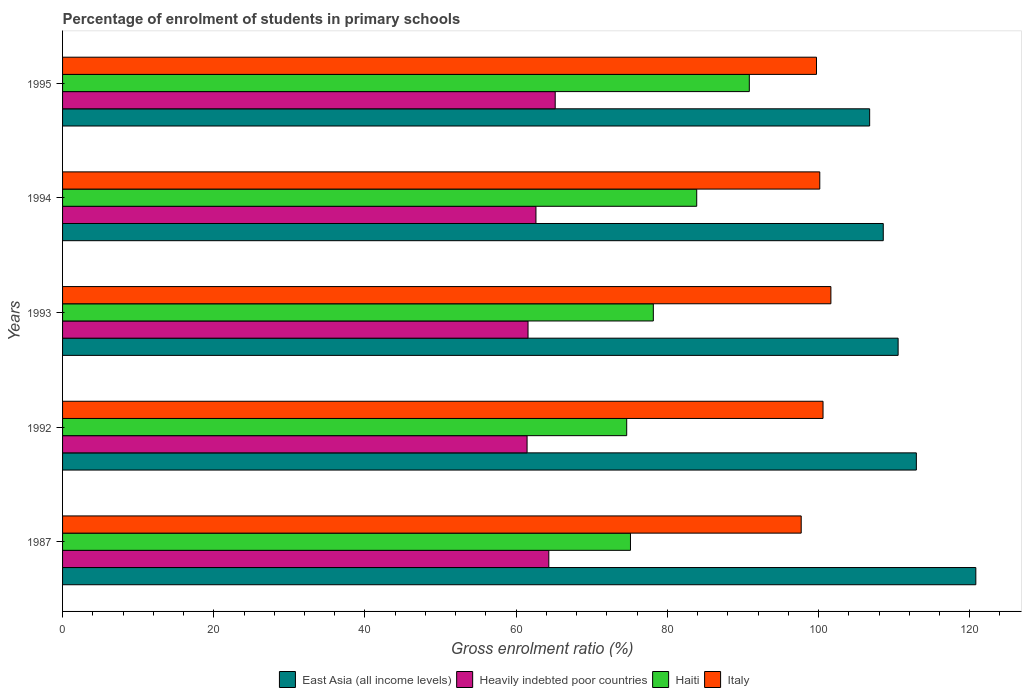How many different coloured bars are there?
Offer a terse response. 4. How many groups of bars are there?
Offer a very short reply. 5. Are the number of bars per tick equal to the number of legend labels?
Ensure brevity in your answer.  Yes. Are the number of bars on each tick of the Y-axis equal?
Your response must be concise. Yes. How many bars are there on the 1st tick from the top?
Make the answer very short. 4. How many bars are there on the 5th tick from the bottom?
Provide a short and direct response. 4. What is the label of the 2nd group of bars from the top?
Provide a succinct answer. 1994. What is the percentage of students enrolled in primary schools in Heavily indebted poor countries in 1995?
Provide a short and direct response. 65.17. Across all years, what is the maximum percentage of students enrolled in primary schools in Heavily indebted poor countries?
Offer a terse response. 65.17. Across all years, what is the minimum percentage of students enrolled in primary schools in Italy?
Ensure brevity in your answer.  97.71. In which year was the percentage of students enrolled in primary schools in Heavily indebted poor countries minimum?
Provide a succinct answer. 1992. What is the total percentage of students enrolled in primary schools in East Asia (all income levels) in the graph?
Keep it short and to the point. 559.62. What is the difference between the percentage of students enrolled in primary schools in East Asia (all income levels) in 1992 and that in 1995?
Give a very brief answer. 6.18. What is the difference between the percentage of students enrolled in primary schools in East Asia (all income levels) in 1992 and the percentage of students enrolled in primary schools in Haiti in 1995?
Your answer should be very brief. 22.1. What is the average percentage of students enrolled in primary schools in Haiti per year?
Your answer should be very brief. 80.53. In the year 1994, what is the difference between the percentage of students enrolled in primary schools in East Asia (all income levels) and percentage of students enrolled in primary schools in Italy?
Give a very brief answer. 8.4. What is the ratio of the percentage of students enrolled in primary schools in Heavily indebted poor countries in 1987 to that in 1993?
Make the answer very short. 1.04. Is the difference between the percentage of students enrolled in primary schools in East Asia (all income levels) in 1987 and 1995 greater than the difference between the percentage of students enrolled in primary schools in Italy in 1987 and 1995?
Your answer should be compact. Yes. What is the difference between the highest and the second highest percentage of students enrolled in primary schools in Heavily indebted poor countries?
Your response must be concise. 0.85. What is the difference between the highest and the lowest percentage of students enrolled in primary schools in East Asia (all income levels)?
Your answer should be very brief. 14.04. What does the 4th bar from the top in 1995 represents?
Offer a terse response. East Asia (all income levels). What does the 3rd bar from the bottom in 1994 represents?
Provide a succinct answer. Haiti. Are the values on the major ticks of X-axis written in scientific E-notation?
Your response must be concise. No. How many legend labels are there?
Your response must be concise. 4. How are the legend labels stacked?
Your response must be concise. Horizontal. What is the title of the graph?
Keep it short and to the point. Percentage of enrolment of students in primary schools. What is the label or title of the X-axis?
Offer a very short reply. Gross enrolment ratio (%). What is the Gross enrolment ratio (%) in East Asia (all income levels) in 1987?
Give a very brief answer. 120.81. What is the Gross enrolment ratio (%) of Heavily indebted poor countries in 1987?
Provide a short and direct response. 64.32. What is the Gross enrolment ratio (%) in Haiti in 1987?
Your answer should be compact. 75.12. What is the Gross enrolment ratio (%) in Italy in 1987?
Keep it short and to the point. 97.71. What is the Gross enrolment ratio (%) in East Asia (all income levels) in 1992?
Your answer should be very brief. 112.94. What is the Gross enrolment ratio (%) in Heavily indebted poor countries in 1992?
Offer a very short reply. 61.45. What is the Gross enrolment ratio (%) in Haiti in 1992?
Offer a terse response. 74.63. What is the Gross enrolment ratio (%) of Italy in 1992?
Keep it short and to the point. 100.6. What is the Gross enrolment ratio (%) in East Asia (all income levels) in 1993?
Your response must be concise. 110.53. What is the Gross enrolment ratio (%) of Heavily indebted poor countries in 1993?
Give a very brief answer. 61.57. What is the Gross enrolment ratio (%) in Haiti in 1993?
Give a very brief answer. 78.15. What is the Gross enrolment ratio (%) in Italy in 1993?
Your answer should be very brief. 101.64. What is the Gross enrolment ratio (%) of East Asia (all income levels) in 1994?
Offer a very short reply. 108.56. What is the Gross enrolment ratio (%) in Heavily indebted poor countries in 1994?
Ensure brevity in your answer.  62.62. What is the Gross enrolment ratio (%) in Haiti in 1994?
Make the answer very short. 83.89. What is the Gross enrolment ratio (%) of Italy in 1994?
Keep it short and to the point. 100.17. What is the Gross enrolment ratio (%) of East Asia (all income levels) in 1995?
Ensure brevity in your answer.  106.77. What is the Gross enrolment ratio (%) of Heavily indebted poor countries in 1995?
Your answer should be very brief. 65.17. What is the Gross enrolment ratio (%) of Haiti in 1995?
Provide a short and direct response. 90.84. What is the Gross enrolment ratio (%) in Italy in 1995?
Keep it short and to the point. 99.73. Across all years, what is the maximum Gross enrolment ratio (%) in East Asia (all income levels)?
Give a very brief answer. 120.81. Across all years, what is the maximum Gross enrolment ratio (%) of Heavily indebted poor countries?
Give a very brief answer. 65.17. Across all years, what is the maximum Gross enrolment ratio (%) in Haiti?
Provide a short and direct response. 90.84. Across all years, what is the maximum Gross enrolment ratio (%) in Italy?
Provide a short and direct response. 101.64. Across all years, what is the minimum Gross enrolment ratio (%) in East Asia (all income levels)?
Make the answer very short. 106.77. Across all years, what is the minimum Gross enrolment ratio (%) in Heavily indebted poor countries?
Provide a short and direct response. 61.45. Across all years, what is the minimum Gross enrolment ratio (%) in Haiti?
Your answer should be very brief. 74.63. Across all years, what is the minimum Gross enrolment ratio (%) in Italy?
Your response must be concise. 97.71. What is the total Gross enrolment ratio (%) in East Asia (all income levels) in the graph?
Offer a terse response. 559.62. What is the total Gross enrolment ratio (%) of Heavily indebted poor countries in the graph?
Provide a short and direct response. 315.13. What is the total Gross enrolment ratio (%) in Haiti in the graph?
Keep it short and to the point. 402.63. What is the total Gross enrolment ratio (%) in Italy in the graph?
Provide a succinct answer. 499.84. What is the difference between the Gross enrolment ratio (%) of East Asia (all income levels) in 1987 and that in 1992?
Your answer should be very brief. 7.87. What is the difference between the Gross enrolment ratio (%) of Heavily indebted poor countries in 1987 and that in 1992?
Your response must be concise. 2.87. What is the difference between the Gross enrolment ratio (%) in Haiti in 1987 and that in 1992?
Your answer should be very brief. 0.5. What is the difference between the Gross enrolment ratio (%) of Italy in 1987 and that in 1992?
Ensure brevity in your answer.  -2.89. What is the difference between the Gross enrolment ratio (%) of East Asia (all income levels) in 1987 and that in 1993?
Give a very brief answer. 10.28. What is the difference between the Gross enrolment ratio (%) of Heavily indebted poor countries in 1987 and that in 1993?
Keep it short and to the point. 2.75. What is the difference between the Gross enrolment ratio (%) in Haiti in 1987 and that in 1993?
Provide a succinct answer. -3.02. What is the difference between the Gross enrolment ratio (%) of Italy in 1987 and that in 1993?
Provide a succinct answer. -3.93. What is the difference between the Gross enrolment ratio (%) in East Asia (all income levels) in 1987 and that in 1994?
Your answer should be compact. 12.25. What is the difference between the Gross enrolment ratio (%) in Heavily indebted poor countries in 1987 and that in 1994?
Provide a short and direct response. 1.7. What is the difference between the Gross enrolment ratio (%) in Haiti in 1987 and that in 1994?
Your answer should be compact. -8.76. What is the difference between the Gross enrolment ratio (%) of Italy in 1987 and that in 1994?
Make the answer very short. -2.46. What is the difference between the Gross enrolment ratio (%) of East Asia (all income levels) in 1987 and that in 1995?
Offer a terse response. 14.04. What is the difference between the Gross enrolment ratio (%) of Heavily indebted poor countries in 1987 and that in 1995?
Provide a short and direct response. -0.85. What is the difference between the Gross enrolment ratio (%) in Haiti in 1987 and that in 1995?
Make the answer very short. -15.72. What is the difference between the Gross enrolment ratio (%) of Italy in 1987 and that in 1995?
Make the answer very short. -2.02. What is the difference between the Gross enrolment ratio (%) in East Asia (all income levels) in 1992 and that in 1993?
Offer a terse response. 2.41. What is the difference between the Gross enrolment ratio (%) in Heavily indebted poor countries in 1992 and that in 1993?
Make the answer very short. -0.13. What is the difference between the Gross enrolment ratio (%) in Haiti in 1992 and that in 1993?
Your answer should be compact. -3.52. What is the difference between the Gross enrolment ratio (%) in Italy in 1992 and that in 1993?
Offer a very short reply. -1.04. What is the difference between the Gross enrolment ratio (%) of East Asia (all income levels) in 1992 and that in 1994?
Provide a succinct answer. 4.38. What is the difference between the Gross enrolment ratio (%) in Heavily indebted poor countries in 1992 and that in 1994?
Your response must be concise. -1.17. What is the difference between the Gross enrolment ratio (%) in Haiti in 1992 and that in 1994?
Keep it short and to the point. -9.26. What is the difference between the Gross enrolment ratio (%) of Italy in 1992 and that in 1994?
Your response must be concise. 0.43. What is the difference between the Gross enrolment ratio (%) of East Asia (all income levels) in 1992 and that in 1995?
Your response must be concise. 6.18. What is the difference between the Gross enrolment ratio (%) of Heavily indebted poor countries in 1992 and that in 1995?
Give a very brief answer. -3.72. What is the difference between the Gross enrolment ratio (%) in Haiti in 1992 and that in 1995?
Make the answer very short. -16.22. What is the difference between the Gross enrolment ratio (%) in Italy in 1992 and that in 1995?
Keep it short and to the point. 0.86. What is the difference between the Gross enrolment ratio (%) of East Asia (all income levels) in 1993 and that in 1994?
Your answer should be compact. 1.97. What is the difference between the Gross enrolment ratio (%) of Heavily indebted poor countries in 1993 and that in 1994?
Your answer should be very brief. -1.05. What is the difference between the Gross enrolment ratio (%) of Haiti in 1993 and that in 1994?
Ensure brevity in your answer.  -5.74. What is the difference between the Gross enrolment ratio (%) in Italy in 1993 and that in 1994?
Your answer should be very brief. 1.47. What is the difference between the Gross enrolment ratio (%) in East Asia (all income levels) in 1993 and that in 1995?
Your answer should be compact. 3.77. What is the difference between the Gross enrolment ratio (%) of Heavily indebted poor countries in 1993 and that in 1995?
Offer a terse response. -3.59. What is the difference between the Gross enrolment ratio (%) of Haiti in 1993 and that in 1995?
Provide a succinct answer. -12.7. What is the difference between the Gross enrolment ratio (%) in Italy in 1993 and that in 1995?
Offer a terse response. 1.9. What is the difference between the Gross enrolment ratio (%) of East Asia (all income levels) in 1994 and that in 1995?
Provide a short and direct response. 1.8. What is the difference between the Gross enrolment ratio (%) in Heavily indebted poor countries in 1994 and that in 1995?
Provide a short and direct response. -2.55. What is the difference between the Gross enrolment ratio (%) in Haiti in 1994 and that in 1995?
Make the answer very short. -6.96. What is the difference between the Gross enrolment ratio (%) in Italy in 1994 and that in 1995?
Provide a succinct answer. 0.43. What is the difference between the Gross enrolment ratio (%) in East Asia (all income levels) in 1987 and the Gross enrolment ratio (%) in Heavily indebted poor countries in 1992?
Keep it short and to the point. 59.36. What is the difference between the Gross enrolment ratio (%) in East Asia (all income levels) in 1987 and the Gross enrolment ratio (%) in Haiti in 1992?
Offer a terse response. 46.18. What is the difference between the Gross enrolment ratio (%) in East Asia (all income levels) in 1987 and the Gross enrolment ratio (%) in Italy in 1992?
Provide a succinct answer. 20.21. What is the difference between the Gross enrolment ratio (%) in Heavily indebted poor countries in 1987 and the Gross enrolment ratio (%) in Haiti in 1992?
Provide a succinct answer. -10.3. What is the difference between the Gross enrolment ratio (%) in Heavily indebted poor countries in 1987 and the Gross enrolment ratio (%) in Italy in 1992?
Make the answer very short. -36.27. What is the difference between the Gross enrolment ratio (%) in Haiti in 1987 and the Gross enrolment ratio (%) in Italy in 1992?
Offer a very short reply. -25.47. What is the difference between the Gross enrolment ratio (%) in East Asia (all income levels) in 1987 and the Gross enrolment ratio (%) in Heavily indebted poor countries in 1993?
Make the answer very short. 59.24. What is the difference between the Gross enrolment ratio (%) of East Asia (all income levels) in 1987 and the Gross enrolment ratio (%) of Haiti in 1993?
Your response must be concise. 42.66. What is the difference between the Gross enrolment ratio (%) in East Asia (all income levels) in 1987 and the Gross enrolment ratio (%) in Italy in 1993?
Your response must be concise. 19.17. What is the difference between the Gross enrolment ratio (%) of Heavily indebted poor countries in 1987 and the Gross enrolment ratio (%) of Haiti in 1993?
Offer a terse response. -13.83. What is the difference between the Gross enrolment ratio (%) of Heavily indebted poor countries in 1987 and the Gross enrolment ratio (%) of Italy in 1993?
Your response must be concise. -37.31. What is the difference between the Gross enrolment ratio (%) of Haiti in 1987 and the Gross enrolment ratio (%) of Italy in 1993?
Your answer should be compact. -26.51. What is the difference between the Gross enrolment ratio (%) of East Asia (all income levels) in 1987 and the Gross enrolment ratio (%) of Heavily indebted poor countries in 1994?
Offer a terse response. 58.19. What is the difference between the Gross enrolment ratio (%) in East Asia (all income levels) in 1987 and the Gross enrolment ratio (%) in Haiti in 1994?
Offer a very short reply. 36.92. What is the difference between the Gross enrolment ratio (%) of East Asia (all income levels) in 1987 and the Gross enrolment ratio (%) of Italy in 1994?
Provide a short and direct response. 20.64. What is the difference between the Gross enrolment ratio (%) of Heavily indebted poor countries in 1987 and the Gross enrolment ratio (%) of Haiti in 1994?
Offer a very short reply. -19.57. What is the difference between the Gross enrolment ratio (%) of Heavily indebted poor countries in 1987 and the Gross enrolment ratio (%) of Italy in 1994?
Provide a succinct answer. -35.84. What is the difference between the Gross enrolment ratio (%) of Haiti in 1987 and the Gross enrolment ratio (%) of Italy in 1994?
Make the answer very short. -25.04. What is the difference between the Gross enrolment ratio (%) of East Asia (all income levels) in 1987 and the Gross enrolment ratio (%) of Heavily indebted poor countries in 1995?
Provide a succinct answer. 55.64. What is the difference between the Gross enrolment ratio (%) in East Asia (all income levels) in 1987 and the Gross enrolment ratio (%) in Haiti in 1995?
Your response must be concise. 29.97. What is the difference between the Gross enrolment ratio (%) of East Asia (all income levels) in 1987 and the Gross enrolment ratio (%) of Italy in 1995?
Give a very brief answer. 21.08. What is the difference between the Gross enrolment ratio (%) of Heavily indebted poor countries in 1987 and the Gross enrolment ratio (%) of Haiti in 1995?
Offer a terse response. -26.52. What is the difference between the Gross enrolment ratio (%) in Heavily indebted poor countries in 1987 and the Gross enrolment ratio (%) in Italy in 1995?
Your answer should be compact. -35.41. What is the difference between the Gross enrolment ratio (%) of Haiti in 1987 and the Gross enrolment ratio (%) of Italy in 1995?
Keep it short and to the point. -24.61. What is the difference between the Gross enrolment ratio (%) of East Asia (all income levels) in 1992 and the Gross enrolment ratio (%) of Heavily indebted poor countries in 1993?
Give a very brief answer. 51.37. What is the difference between the Gross enrolment ratio (%) in East Asia (all income levels) in 1992 and the Gross enrolment ratio (%) in Haiti in 1993?
Give a very brief answer. 34.79. What is the difference between the Gross enrolment ratio (%) of East Asia (all income levels) in 1992 and the Gross enrolment ratio (%) of Italy in 1993?
Provide a short and direct response. 11.31. What is the difference between the Gross enrolment ratio (%) in Heavily indebted poor countries in 1992 and the Gross enrolment ratio (%) in Haiti in 1993?
Give a very brief answer. -16.7. What is the difference between the Gross enrolment ratio (%) in Heavily indebted poor countries in 1992 and the Gross enrolment ratio (%) in Italy in 1993?
Ensure brevity in your answer.  -40.19. What is the difference between the Gross enrolment ratio (%) of Haiti in 1992 and the Gross enrolment ratio (%) of Italy in 1993?
Ensure brevity in your answer.  -27.01. What is the difference between the Gross enrolment ratio (%) of East Asia (all income levels) in 1992 and the Gross enrolment ratio (%) of Heavily indebted poor countries in 1994?
Provide a short and direct response. 50.32. What is the difference between the Gross enrolment ratio (%) of East Asia (all income levels) in 1992 and the Gross enrolment ratio (%) of Haiti in 1994?
Ensure brevity in your answer.  29.05. What is the difference between the Gross enrolment ratio (%) in East Asia (all income levels) in 1992 and the Gross enrolment ratio (%) in Italy in 1994?
Ensure brevity in your answer.  12.78. What is the difference between the Gross enrolment ratio (%) of Heavily indebted poor countries in 1992 and the Gross enrolment ratio (%) of Haiti in 1994?
Ensure brevity in your answer.  -22.44. What is the difference between the Gross enrolment ratio (%) in Heavily indebted poor countries in 1992 and the Gross enrolment ratio (%) in Italy in 1994?
Provide a succinct answer. -38.72. What is the difference between the Gross enrolment ratio (%) of Haiti in 1992 and the Gross enrolment ratio (%) of Italy in 1994?
Provide a short and direct response. -25.54. What is the difference between the Gross enrolment ratio (%) of East Asia (all income levels) in 1992 and the Gross enrolment ratio (%) of Heavily indebted poor countries in 1995?
Provide a succinct answer. 47.77. What is the difference between the Gross enrolment ratio (%) in East Asia (all income levels) in 1992 and the Gross enrolment ratio (%) in Haiti in 1995?
Make the answer very short. 22.1. What is the difference between the Gross enrolment ratio (%) in East Asia (all income levels) in 1992 and the Gross enrolment ratio (%) in Italy in 1995?
Provide a succinct answer. 13.21. What is the difference between the Gross enrolment ratio (%) in Heavily indebted poor countries in 1992 and the Gross enrolment ratio (%) in Haiti in 1995?
Your answer should be compact. -29.4. What is the difference between the Gross enrolment ratio (%) in Heavily indebted poor countries in 1992 and the Gross enrolment ratio (%) in Italy in 1995?
Your response must be concise. -38.28. What is the difference between the Gross enrolment ratio (%) in Haiti in 1992 and the Gross enrolment ratio (%) in Italy in 1995?
Ensure brevity in your answer.  -25.11. What is the difference between the Gross enrolment ratio (%) in East Asia (all income levels) in 1993 and the Gross enrolment ratio (%) in Heavily indebted poor countries in 1994?
Your answer should be compact. 47.91. What is the difference between the Gross enrolment ratio (%) in East Asia (all income levels) in 1993 and the Gross enrolment ratio (%) in Haiti in 1994?
Offer a terse response. 26.64. What is the difference between the Gross enrolment ratio (%) in East Asia (all income levels) in 1993 and the Gross enrolment ratio (%) in Italy in 1994?
Keep it short and to the point. 10.36. What is the difference between the Gross enrolment ratio (%) of Heavily indebted poor countries in 1993 and the Gross enrolment ratio (%) of Haiti in 1994?
Provide a succinct answer. -22.31. What is the difference between the Gross enrolment ratio (%) in Heavily indebted poor countries in 1993 and the Gross enrolment ratio (%) in Italy in 1994?
Ensure brevity in your answer.  -38.59. What is the difference between the Gross enrolment ratio (%) in Haiti in 1993 and the Gross enrolment ratio (%) in Italy in 1994?
Give a very brief answer. -22.02. What is the difference between the Gross enrolment ratio (%) of East Asia (all income levels) in 1993 and the Gross enrolment ratio (%) of Heavily indebted poor countries in 1995?
Offer a very short reply. 45.36. What is the difference between the Gross enrolment ratio (%) of East Asia (all income levels) in 1993 and the Gross enrolment ratio (%) of Haiti in 1995?
Give a very brief answer. 19.69. What is the difference between the Gross enrolment ratio (%) of East Asia (all income levels) in 1993 and the Gross enrolment ratio (%) of Italy in 1995?
Ensure brevity in your answer.  10.8. What is the difference between the Gross enrolment ratio (%) in Heavily indebted poor countries in 1993 and the Gross enrolment ratio (%) in Haiti in 1995?
Provide a succinct answer. -29.27. What is the difference between the Gross enrolment ratio (%) of Heavily indebted poor countries in 1993 and the Gross enrolment ratio (%) of Italy in 1995?
Give a very brief answer. -38.16. What is the difference between the Gross enrolment ratio (%) in Haiti in 1993 and the Gross enrolment ratio (%) in Italy in 1995?
Your answer should be very brief. -21.58. What is the difference between the Gross enrolment ratio (%) of East Asia (all income levels) in 1994 and the Gross enrolment ratio (%) of Heavily indebted poor countries in 1995?
Keep it short and to the point. 43.4. What is the difference between the Gross enrolment ratio (%) in East Asia (all income levels) in 1994 and the Gross enrolment ratio (%) in Haiti in 1995?
Provide a short and direct response. 17.72. What is the difference between the Gross enrolment ratio (%) of East Asia (all income levels) in 1994 and the Gross enrolment ratio (%) of Italy in 1995?
Your answer should be compact. 8.83. What is the difference between the Gross enrolment ratio (%) of Heavily indebted poor countries in 1994 and the Gross enrolment ratio (%) of Haiti in 1995?
Your response must be concise. -28.22. What is the difference between the Gross enrolment ratio (%) of Heavily indebted poor countries in 1994 and the Gross enrolment ratio (%) of Italy in 1995?
Offer a very short reply. -37.11. What is the difference between the Gross enrolment ratio (%) of Haiti in 1994 and the Gross enrolment ratio (%) of Italy in 1995?
Keep it short and to the point. -15.84. What is the average Gross enrolment ratio (%) in East Asia (all income levels) per year?
Offer a very short reply. 111.92. What is the average Gross enrolment ratio (%) in Heavily indebted poor countries per year?
Your response must be concise. 63.03. What is the average Gross enrolment ratio (%) in Haiti per year?
Give a very brief answer. 80.53. What is the average Gross enrolment ratio (%) of Italy per year?
Make the answer very short. 99.97. In the year 1987, what is the difference between the Gross enrolment ratio (%) in East Asia (all income levels) and Gross enrolment ratio (%) in Heavily indebted poor countries?
Your answer should be very brief. 56.49. In the year 1987, what is the difference between the Gross enrolment ratio (%) of East Asia (all income levels) and Gross enrolment ratio (%) of Haiti?
Give a very brief answer. 45.69. In the year 1987, what is the difference between the Gross enrolment ratio (%) of East Asia (all income levels) and Gross enrolment ratio (%) of Italy?
Your response must be concise. 23.1. In the year 1987, what is the difference between the Gross enrolment ratio (%) in Heavily indebted poor countries and Gross enrolment ratio (%) in Haiti?
Your response must be concise. -10.8. In the year 1987, what is the difference between the Gross enrolment ratio (%) in Heavily indebted poor countries and Gross enrolment ratio (%) in Italy?
Ensure brevity in your answer.  -33.39. In the year 1987, what is the difference between the Gross enrolment ratio (%) in Haiti and Gross enrolment ratio (%) in Italy?
Offer a very short reply. -22.58. In the year 1992, what is the difference between the Gross enrolment ratio (%) of East Asia (all income levels) and Gross enrolment ratio (%) of Heavily indebted poor countries?
Give a very brief answer. 51.5. In the year 1992, what is the difference between the Gross enrolment ratio (%) in East Asia (all income levels) and Gross enrolment ratio (%) in Haiti?
Ensure brevity in your answer.  38.32. In the year 1992, what is the difference between the Gross enrolment ratio (%) of East Asia (all income levels) and Gross enrolment ratio (%) of Italy?
Keep it short and to the point. 12.35. In the year 1992, what is the difference between the Gross enrolment ratio (%) of Heavily indebted poor countries and Gross enrolment ratio (%) of Haiti?
Make the answer very short. -13.18. In the year 1992, what is the difference between the Gross enrolment ratio (%) in Heavily indebted poor countries and Gross enrolment ratio (%) in Italy?
Provide a short and direct response. -39.15. In the year 1992, what is the difference between the Gross enrolment ratio (%) of Haiti and Gross enrolment ratio (%) of Italy?
Ensure brevity in your answer.  -25.97. In the year 1993, what is the difference between the Gross enrolment ratio (%) in East Asia (all income levels) and Gross enrolment ratio (%) in Heavily indebted poor countries?
Offer a terse response. 48.96. In the year 1993, what is the difference between the Gross enrolment ratio (%) of East Asia (all income levels) and Gross enrolment ratio (%) of Haiti?
Make the answer very short. 32.38. In the year 1993, what is the difference between the Gross enrolment ratio (%) of East Asia (all income levels) and Gross enrolment ratio (%) of Italy?
Make the answer very short. 8.89. In the year 1993, what is the difference between the Gross enrolment ratio (%) in Heavily indebted poor countries and Gross enrolment ratio (%) in Haiti?
Keep it short and to the point. -16.57. In the year 1993, what is the difference between the Gross enrolment ratio (%) in Heavily indebted poor countries and Gross enrolment ratio (%) in Italy?
Ensure brevity in your answer.  -40.06. In the year 1993, what is the difference between the Gross enrolment ratio (%) of Haiti and Gross enrolment ratio (%) of Italy?
Provide a short and direct response. -23.49. In the year 1994, what is the difference between the Gross enrolment ratio (%) of East Asia (all income levels) and Gross enrolment ratio (%) of Heavily indebted poor countries?
Offer a very short reply. 45.94. In the year 1994, what is the difference between the Gross enrolment ratio (%) of East Asia (all income levels) and Gross enrolment ratio (%) of Haiti?
Make the answer very short. 24.68. In the year 1994, what is the difference between the Gross enrolment ratio (%) in East Asia (all income levels) and Gross enrolment ratio (%) in Italy?
Provide a short and direct response. 8.4. In the year 1994, what is the difference between the Gross enrolment ratio (%) of Heavily indebted poor countries and Gross enrolment ratio (%) of Haiti?
Make the answer very short. -21.27. In the year 1994, what is the difference between the Gross enrolment ratio (%) in Heavily indebted poor countries and Gross enrolment ratio (%) in Italy?
Provide a short and direct response. -37.55. In the year 1994, what is the difference between the Gross enrolment ratio (%) in Haiti and Gross enrolment ratio (%) in Italy?
Give a very brief answer. -16.28. In the year 1995, what is the difference between the Gross enrolment ratio (%) in East Asia (all income levels) and Gross enrolment ratio (%) in Heavily indebted poor countries?
Provide a short and direct response. 41.6. In the year 1995, what is the difference between the Gross enrolment ratio (%) in East Asia (all income levels) and Gross enrolment ratio (%) in Haiti?
Make the answer very short. 15.92. In the year 1995, what is the difference between the Gross enrolment ratio (%) in East Asia (all income levels) and Gross enrolment ratio (%) in Italy?
Make the answer very short. 7.03. In the year 1995, what is the difference between the Gross enrolment ratio (%) in Heavily indebted poor countries and Gross enrolment ratio (%) in Haiti?
Your answer should be compact. -25.68. In the year 1995, what is the difference between the Gross enrolment ratio (%) of Heavily indebted poor countries and Gross enrolment ratio (%) of Italy?
Ensure brevity in your answer.  -34.56. In the year 1995, what is the difference between the Gross enrolment ratio (%) in Haiti and Gross enrolment ratio (%) in Italy?
Give a very brief answer. -8.89. What is the ratio of the Gross enrolment ratio (%) of East Asia (all income levels) in 1987 to that in 1992?
Give a very brief answer. 1.07. What is the ratio of the Gross enrolment ratio (%) in Heavily indebted poor countries in 1987 to that in 1992?
Give a very brief answer. 1.05. What is the ratio of the Gross enrolment ratio (%) of Haiti in 1987 to that in 1992?
Give a very brief answer. 1.01. What is the ratio of the Gross enrolment ratio (%) of Italy in 1987 to that in 1992?
Offer a terse response. 0.97. What is the ratio of the Gross enrolment ratio (%) of East Asia (all income levels) in 1987 to that in 1993?
Provide a short and direct response. 1.09. What is the ratio of the Gross enrolment ratio (%) in Heavily indebted poor countries in 1987 to that in 1993?
Your answer should be compact. 1.04. What is the ratio of the Gross enrolment ratio (%) of Haiti in 1987 to that in 1993?
Provide a short and direct response. 0.96. What is the ratio of the Gross enrolment ratio (%) of Italy in 1987 to that in 1993?
Make the answer very short. 0.96. What is the ratio of the Gross enrolment ratio (%) in East Asia (all income levels) in 1987 to that in 1994?
Offer a very short reply. 1.11. What is the ratio of the Gross enrolment ratio (%) in Heavily indebted poor countries in 1987 to that in 1994?
Give a very brief answer. 1.03. What is the ratio of the Gross enrolment ratio (%) of Haiti in 1987 to that in 1994?
Offer a terse response. 0.9. What is the ratio of the Gross enrolment ratio (%) in Italy in 1987 to that in 1994?
Your answer should be compact. 0.98. What is the ratio of the Gross enrolment ratio (%) of East Asia (all income levels) in 1987 to that in 1995?
Offer a very short reply. 1.13. What is the ratio of the Gross enrolment ratio (%) in Heavily indebted poor countries in 1987 to that in 1995?
Your response must be concise. 0.99. What is the ratio of the Gross enrolment ratio (%) of Haiti in 1987 to that in 1995?
Keep it short and to the point. 0.83. What is the ratio of the Gross enrolment ratio (%) in Italy in 1987 to that in 1995?
Your answer should be compact. 0.98. What is the ratio of the Gross enrolment ratio (%) of East Asia (all income levels) in 1992 to that in 1993?
Your answer should be compact. 1.02. What is the ratio of the Gross enrolment ratio (%) in Heavily indebted poor countries in 1992 to that in 1993?
Offer a terse response. 1. What is the ratio of the Gross enrolment ratio (%) in Haiti in 1992 to that in 1993?
Make the answer very short. 0.95. What is the ratio of the Gross enrolment ratio (%) in Italy in 1992 to that in 1993?
Your answer should be compact. 0.99. What is the ratio of the Gross enrolment ratio (%) of East Asia (all income levels) in 1992 to that in 1994?
Your answer should be very brief. 1.04. What is the ratio of the Gross enrolment ratio (%) of Heavily indebted poor countries in 1992 to that in 1994?
Keep it short and to the point. 0.98. What is the ratio of the Gross enrolment ratio (%) in Haiti in 1992 to that in 1994?
Offer a terse response. 0.89. What is the ratio of the Gross enrolment ratio (%) in Italy in 1992 to that in 1994?
Provide a short and direct response. 1. What is the ratio of the Gross enrolment ratio (%) of East Asia (all income levels) in 1992 to that in 1995?
Ensure brevity in your answer.  1.06. What is the ratio of the Gross enrolment ratio (%) in Heavily indebted poor countries in 1992 to that in 1995?
Offer a terse response. 0.94. What is the ratio of the Gross enrolment ratio (%) in Haiti in 1992 to that in 1995?
Provide a succinct answer. 0.82. What is the ratio of the Gross enrolment ratio (%) of Italy in 1992 to that in 1995?
Your answer should be compact. 1.01. What is the ratio of the Gross enrolment ratio (%) in East Asia (all income levels) in 1993 to that in 1994?
Offer a terse response. 1.02. What is the ratio of the Gross enrolment ratio (%) of Heavily indebted poor countries in 1993 to that in 1994?
Ensure brevity in your answer.  0.98. What is the ratio of the Gross enrolment ratio (%) of Haiti in 1993 to that in 1994?
Give a very brief answer. 0.93. What is the ratio of the Gross enrolment ratio (%) in Italy in 1993 to that in 1994?
Your answer should be compact. 1.01. What is the ratio of the Gross enrolment ratio (%) of East Asia (all income levels) in 1993 to that in 1995?
Give a very brief answer. 1.04. What is the ratio of the Gross enrolment ratio (%) in Heavily indebted poor countries in 1993 to that in 1995?
Ensure brevity in your answer.  0.94. What is the ratio of the Gross enrolment ratio (%) of Haiti in 1993 to that in 1995?
Keep it short and to the point. 0.86. What is the ratio of the Gross enrolment ratio (%) of Italy in 1993 to that in 1995?
Make the answer very short. 1.02. What is the ratio of the Gross enrolment ratio (%) of East Asia (all income levels) in 1994 to that in 1995?
Your answer should be compact. 1.02. What is the ratio of the Gross enrolment ratio (%) of Heavily indebted poor countries in 1994 to that in 1995?
Your response must be concise. 0.96. What is the ratio of the Gross enrolment ratio (%) of Haiti in 1994 to that in 1995?
Your answer should be compact. 0.92. What is the ratio of the Gross enrolment ratio (%) in Italy in 1994 to that in 1995?
Provide a short and direct response. 1. What is the difference between the highest and the second highest Gross enrolment ratio (%) in East Asia (all income levels)?
Ensure brevity in your answer.  7.87. What is the difference between the highest and the second highest Gross enrolment ratio (%) of Heavily indebted poor countries?
Your answer should be compact. 0.85. What is the difference between the highest and the second highest Gross enrolment ratio (%) of Haiti?
Provide a succinct answer. 6.96. What is the difference between the highest and the second highest Gross enrolment ratio (%) in Italy?
Ensure brevity in your answer.  1.04. What is the difference between the highest and the lowest Gross enrolment ratio (%) in East Asia (all income levels)?
Your answer should be very brief. 14.04. What is the difference between the highest and the lowest Gross enrolment ratio (%) in Heavily indebted poor countries?
Give a very brief answer. 3.72. What is the difference between the highest and the lowest Gross enrolment ratio (%) in Haiti?
Keep it short and to the point. 16.22. What is the difference between the highest and the lowest Gross enrolment ratio (%) in Italy?
Your answer should be very brief. 3.93. 